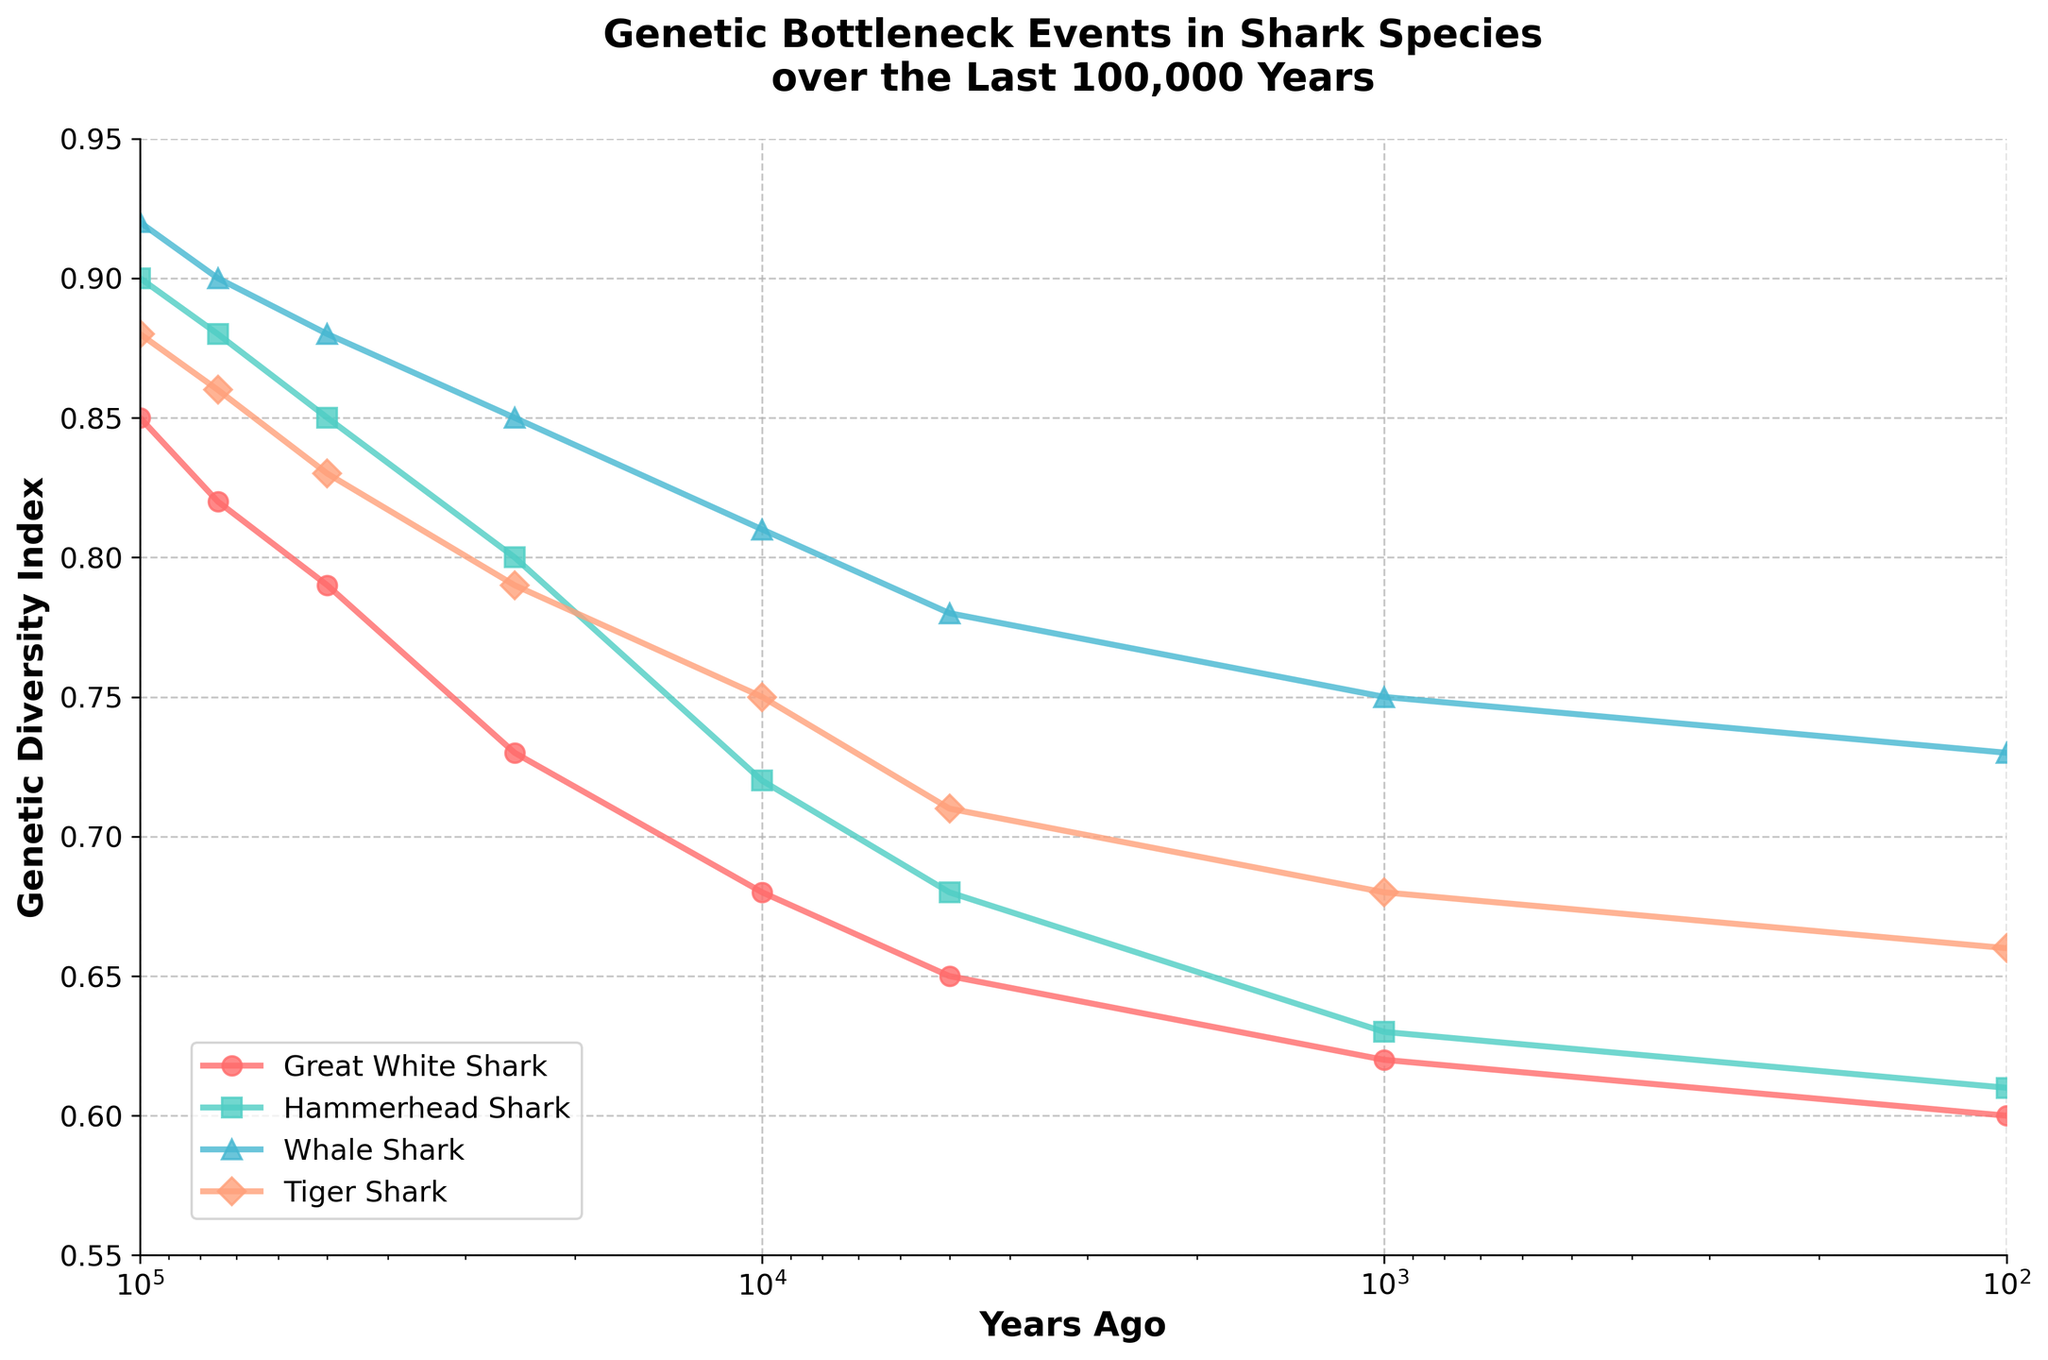How has the genetic diversity index of Great White Sharks changed from 100,000 years ago to 100 years ago? Observe the line representing Great White Sharks. The genetic diversity index has decreased from 0.85 to 0.60 over the last 100,000 years.
Answer: It decreased from 0.85 to 0.60 Which shark species has the highest genetic diversity index 100 years ago? Compare the endpoints at 100 years ago for all species. Whale Sharks have the highest index at 0.73.
Answer: Whale Shark What is the approximate average genetic diversity index of Hammerhead Sharks 10,000 years ago and 1,000 years ago? Add the values at 10,000 years ago (0.72) and 1,000 years ago (0.63) and divide by 2. (0.72 + 0.63) / 2 = 0.675
Answer: 0.675 Which shark species experienced the largest drop in genetic diversity index 25,000 years ago to 10,000 years ago? Calculate the drop for each species: Great White Shark (0.79 to 0.73), Hammerhead Shark (0.80 to 0.72), Whale Shark (0.85 to 0.81), Tiger Shark (0.79 to 0.75). Hammerhead Shark shows the largest drop of 0.08.
Answer: Hammerhead Shark How does the genetic diversity index of Whale Sharks 50,000 years ago compare to that of Tiger Sharks 1,000 years ago? Whale Sharks had a genetic diversity index of 0.88 50,000 years ago, while Tiger Sharks had an index of 0.68 1,000 years ago. Whale Sharks had a higher index.
Answer: Whale Sharks had a higher index at 0.88 Which species shows a consistent decrease in genetic diversity index across all time intervals in the last 100,000 years? Check each species' line for a consistent downward trend: Great White Shark consistently decreases from 0.85 to 0.60.
Answer: Great White Shark From 10,000 years ago to 100 years ago, which species maintained a genetic diversity index above 0.70 at least once? Check this interval for each species. Whale Shark maintained above 0.70 from 10,000 to 100 years ago.
Answer: Whale Shark At what point did the genetic diversity index of Tiger Sharks drop below 0.80? Observe the line for Tiger Sharks. The value dropped below 0.80 between 25,000 and 10,000 years ago.
Answer: Between 25,000 and 10,000 years ago What is the difference in genetic diversity index between Great White Sharks and Hammerhead Sharks 5,000 years ago? Subtract the values at 5,000 years ago: Hammerhead Shark (0.68) - Great White Shark (0.65) = 0.03
Answer: 0.03 Does any species show an increase in genetic diversity index at any point? Examine each species' line for any upward trend. None of the species show an increase; all lines indicate a consistent decrease.
Answer: No 